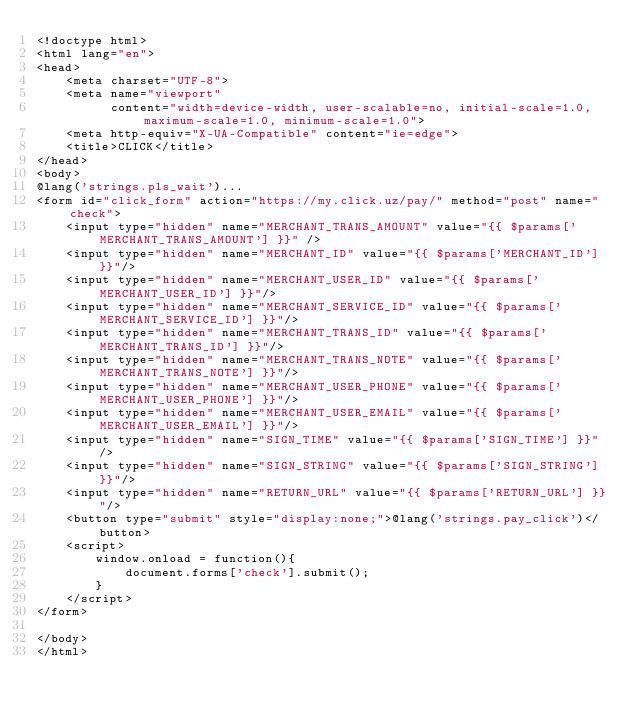Convert code to text. <code><loc_0><loc_0><loc_500><loc_500><_PHP_><!doctype html>
<html lang="en">
<head>
    <meta charset="UTF-8">
    <meta name="viewport"
          content="width=device-width, user-scalable=no, initial-scale=1.0, maximum-scale=1.0, minimum-scale=1.0">
    <meta http-equiv="X-UA-Compatible" content="ie=edge">
    <title>CLICK</title>
</head>
<body>
@lang('strings.pls_wait')...
<form id="click_form" action="https://my.click.uz/pay/" method="post" name="check">
    <input type="hidden" name="MERCHANT_TRANS_AMOUNT" value="{{ $params['MERCHANT_TRANS_AMOUNT'] }}" />
    <input type="hidden" name="MERCHANT_ID" value="{{ $params['MERCHANT_ID'] }}"/>
    <input type="hidden" name="MERCHANT_USER_ID" value="{{ $params['MERCHANT_USER_ID'] }}"/>
    <input type="hidden" name="MERCHANT_SERVICE_ID" value="{{ $params['MERCHANT_SERVICE_ID'] }}"/>
    <input type="hidden" name="MERCHANT_TRANS_ID" value="{{ $params['MERCHANT_TRANS_ID'] }}"/>
    <input type="hidden" name="MERCHANT_TRANS_NOTE" value="{{ $params['MERCHANT_TRANS_NOTE'] }}"/>
    <input type="hidden" name="MERCHANT_USER_PHONE" value="{{ $params['MERCHANT_USER_PHONE'] }}"/>
    <input type="hidden" name="MERCHANT_USER_EMAIL" value="{{ $params['MERCHANT_USER_EMAIL'] }}"/>
    <input type="hidden" name="SIGN_TIME" value="{{ $params['SIGN_TIME'] }}"/>
    <input type="hidden" name="SIGN_STRING" value="{{ $params['SIGN_STRING'] }}"/>
    <input type="hidden" name="RETURN_URL" value="{{ $params['RETURN_URL'] }}"/>
    <button type="submit" style="display:none;">@lang('strings.pay_click')</button>
    <script>
        window.onload = function(){
            document.forms['check'].submit();
        }
    </script>
</form>

</body>
</html>
</code> 